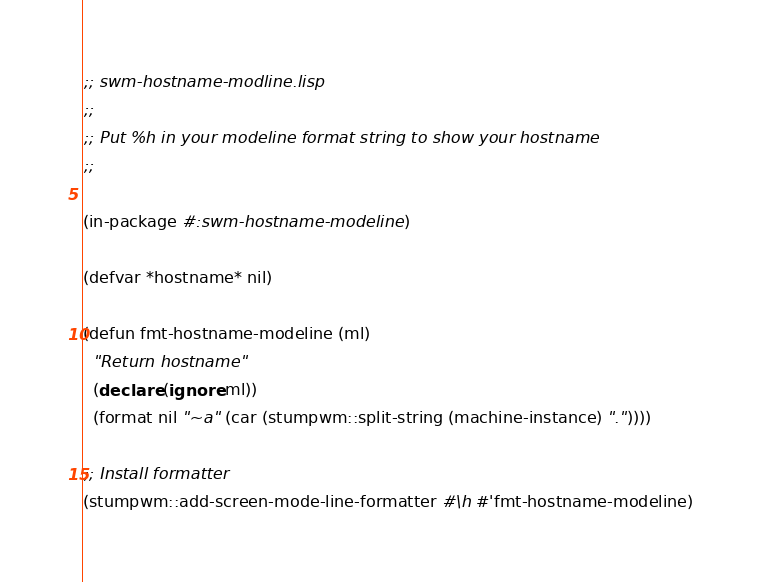Convert code to text. <code><loc_0><loc_0><loc_500><loc_500><_Lisp_>;; swm-hostname-modline.lisp
;;
;; Put %h in your modeline format string to show your hostname
;;

(in-package #:swm-hostname-modeline)

(defvar *hostname* nil)

(defun fmt-hostname-modeline (ml)
  "Return hostname"
  (declare (ignore ml))
  (format nil "~a" (car (stumpwm::split-string (machine-instance) "."))))

;; Install formatter
(stumpwm::add-screen-mode-line-formatter #\h #'fmt-hostname-modeline)

</code> 